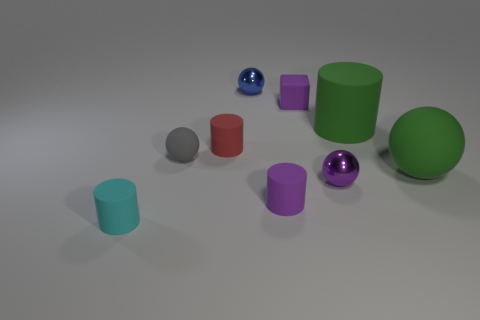Subtract all gray balls. How many balls are left? 3 Subtract 2 cylinders. How many cylinders are left? 2 Add 1 large gray balls. How many objects exist? 10 Subtract all gray balls. How many balls are left? 3 Subtract all blue blocks. Subtract all red spheres. How many blocks are left? 1 Subtract all gray blocks. How many green cylinders are left? 1 Subtract all small cyan objects. Subtract all small cyan cylinders. How many objects are left? 7 Add 6 purple objects. How many purple objects are left? 9 Add 5 tiny blue things. How many tiny blue things exist? 6 Subtract 0 blue cylinders. How many objects are left? 9 